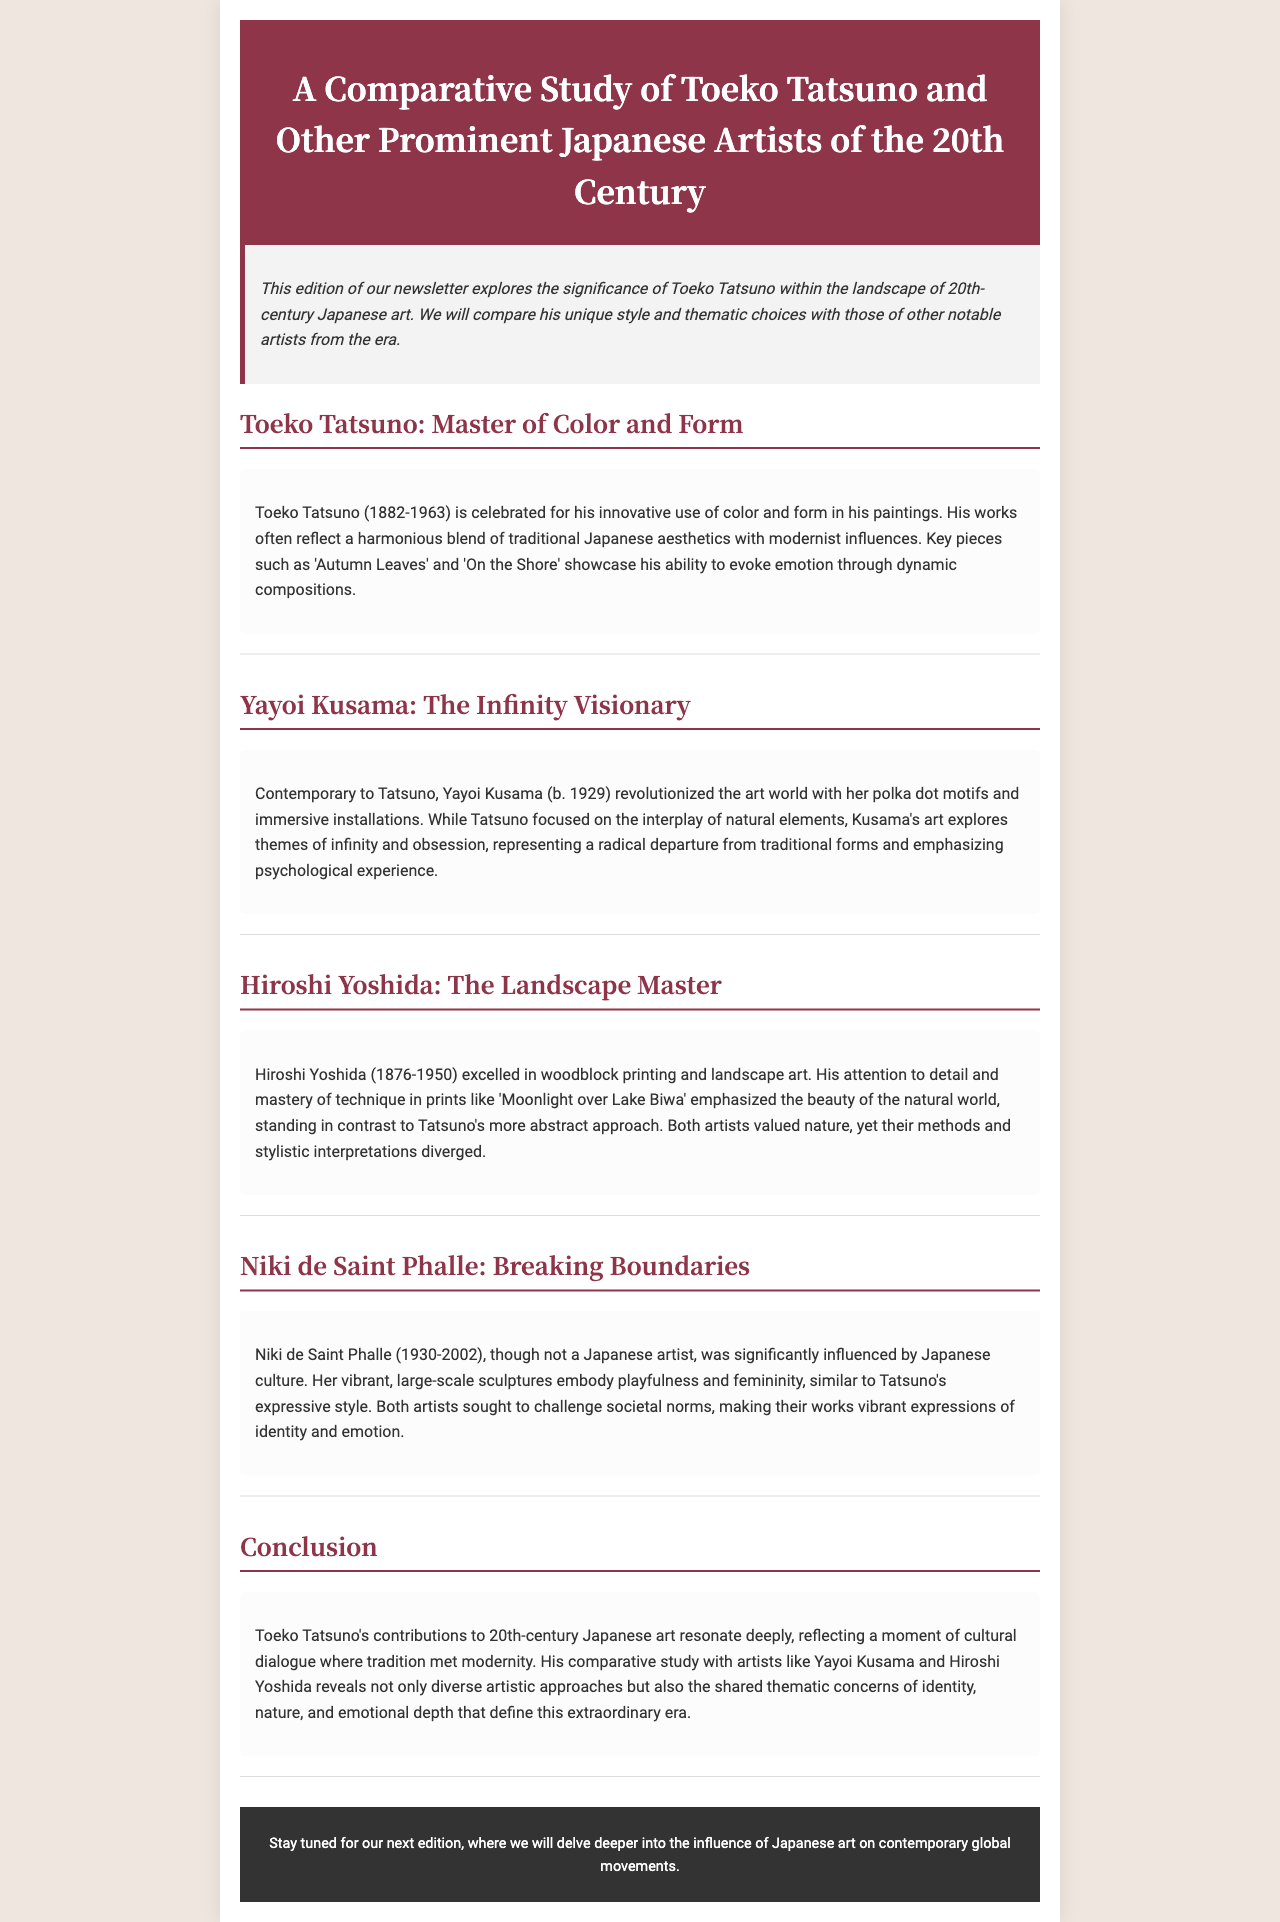What is the title of the newsletter? The title is found in the header section of the document.
Answer: A Comparative Study of Toeko Tatsuno and Other Prominent Japanese Artists of the 20th Century Who is the artist celebrated for his innovative use of color and form? This information is located in the section about Toeko Tatsuno.
Answer: Toeko Tatsuno What year was Toeko Tatsuno born? The document provides this detail in the section about Toeko Tatsuno.
Answer: 1882 Which artist is known for polka dot motifs? This detail is found in the section discussing Yayoi Kusama.
Answer: Yayoi Kusama What type of art did Hiroshi Yoshida excel in? This information is mentioned in the section dedicated to Hiroshi Yoshida.
Answer: Woodblock printing What key theme does Niki de Saint Phalle's art emphasize? The document highlights this theme in the section about Niki de Saint Phalle.
Answer: Playfulness How did Tatsuno's approach to nature differ from Hiroshi Yoshida's? The document discusses the differences in their artistic methods and style.
Answer: Abstract approach What artistic period does the newsletter focus on? The context can be inferred from the title and several sections within the document.
Answer: 20th century In which section can you find a comparative study? The comparative elements are primarily discussed in the conclusion.
Answer: Conclusion 